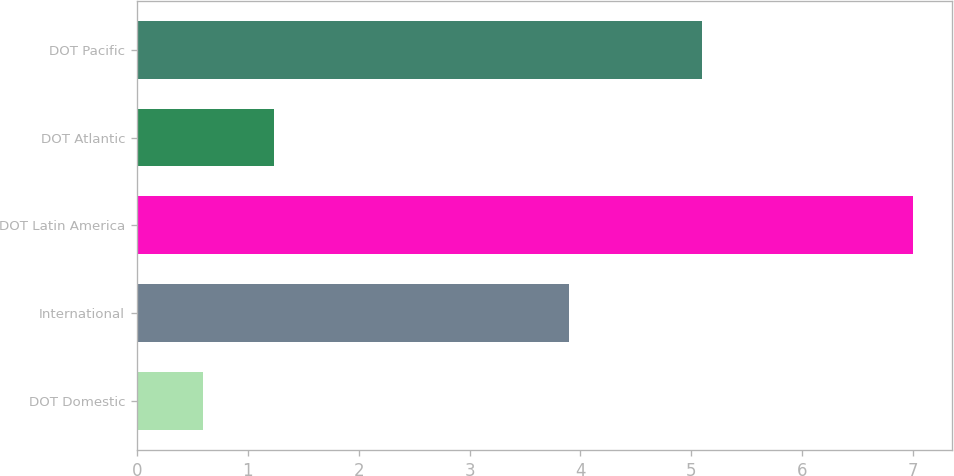Convert chart to OTSL. <chart><loc_0><loc_0><loc_500><loc_500><bar_chart><fcel>DOT Domestic<fcel>International<fcel>DOT Latin America<fcel>DOT Atlantic<fcel>DOT Pacific<nl><fcel>0.6<fcel>3.9<fcel>7<fcel>1.24<fcel>5.1<nl></chart> 